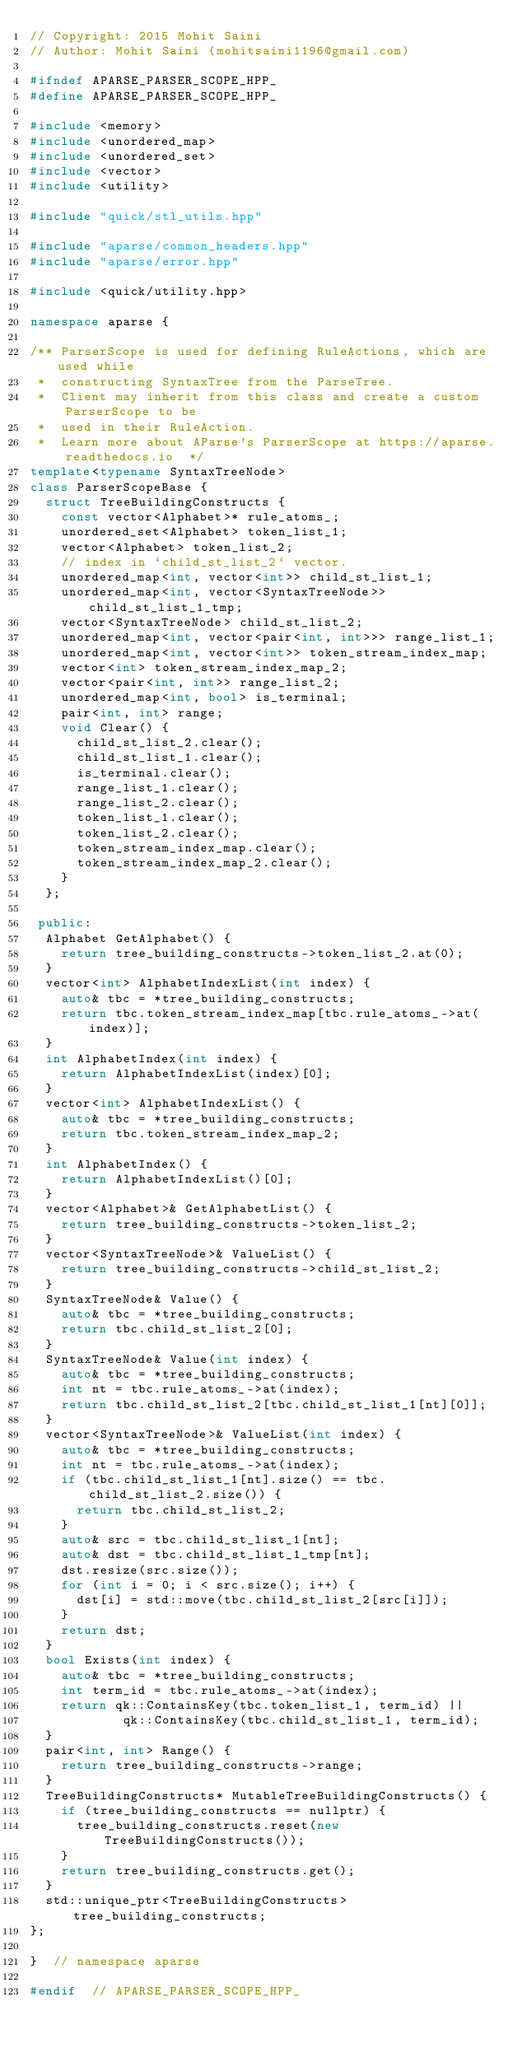<code> <loc_0><loc_0><loc_500><loc_500><_C++_>// Copyright: 2015 Mohit Saini
// Author: Mohit Saini (mohitsaini1196@gmail.com)

#ifndef APARSE_PARSER_SCOPE_HPP_
#define APARSE_PARSER_SCOPE_HPP_

#include <memory>
#include <unordered_map>
#include <unordered_set>
#include <vector>
#include <utility>

#include "quick/stl_utils.hpp"

#include "aparse/common_headers.hpp"
#include "aparse/error.hpp"

#include <quick/utility.hpp>

namespace aparse {

/** ParserScope is used for defining RuleActions, which are used while
 *  constructing SyntaxTree from the ParseTree.
 *  Client may inherit from this class and create a custom ParserScope to be
 *  used in their RuleAction.
 *  Learn more about AParse's ParserScope at https://aparse.readthedocs.io  */
template<typename SyntaxTreeNode>
class ParserScopeBase {
  struct TreeBuildingConstructs {
    const vector<Alphabet>* rule_atoms_;
    unordered_set<Alphabet> token_list_1;
    vector<Alphabet> token_list_2;
    // index in `child_st_list_2` vector.
    unordered_map<int, vector<int>> child_st_list_1;
    unordered_map<int, vector<SyntaxTreeNode>> child_st_list_1_tmp;
    vector<SyntaxTreeNode> child_st_list_2;
    unordered_map<int, vector<pair<int, int>>> range_list_1;
    unordered_map<int, vector<int>> token_stream_index_map;
    vector<int> token_stream_index_map_2;
    vector<pair<int, int>> range_list_2;
    unordered_map<int, bool> is_terminal;
    pair<int, int> range;
    void Clear() {
      child_st_list_2.clear();
      child_st_list_1.clear();
      is_terminal.clear();
      range_list_1.clear();
      range_list_2.clear();
      token_list_1.clear();
      token_list_2.clear();
      token_stream_index_map.clear();
      token_stream_index_map_2.clear();
    }
  };

 public:
  Alphabet GetAlphabet() {
    return tree_building_constructs->token_list_2.at(0);
  }
  vector<int> AlphabetIndexList(int index) {
    auto& tbc = *tree_building_constructs;
    return tbc.token_stream_index_map[tbc.rule_atoms_->at(index)];
  }
  int AlphabetIndex(int index) {
    return AlphabetIndexList(index)[0];
  }
  vector<int> AlphabetIndexList() {
    auto& tbc = *tree_building_constructs;
    return tbc.token_stream_index_map_2;
  }
  int AlphabetIndex() {
    return AlphabetIndexList()[0];
  }
  vector<Alphabet>& GetAlphabetList() {
    return tree_building_constructs->token_list_2;
  }
  vector<SyntaxTreeNode>& ValueList() {
    return tree_building_constructs->child_st_list_2;
  }
  SyntaxTreeNode& Value() {
    auto& tbc = *tree_building_constructs;
    return tbc.child_st_list_2[0];
  }
  SyntaxTreeNode& Value(int index) {
    auto& tbc = *tree_building_constructs;
    int nt = tbc.rule_atoms_->at(index);
    return tbc.child_st_list_2[tbc.child_st_list_1[nt][0]];
  }
  vector<SyntaxTreeNode>& ValueList(int index) {
    auto& tbc = *tree_building_constructs;
    int nt = tbc.rule_atoms_->at(index);
    if (tbc.child_st_list_1[nt].size() == tbc.child_st_list_2.size()) {
      return tbc.child_st_list_2;
    }
    auto& src = tbc.child_st_list_1[nt];
    auto& dst = tbc.child_st_list_1_tmp[nt];
    dst.resize(src.size());
    for (int i = 0; i < src.size(); i++) {
      dst[i] = std::move(tbc.child_st_list_2[src[i]]);
    }
    return dst;
  }
  bool Exists(int index) {
    auto& tbc = *tree_building_constructs;
    int term_id = tbc.rule_atoms_->at(index);
    return qk::ContainsKey(tbc.token_list_1, term_id) ||
            qk::ContainsKey(tbc.child_st_list_1, term_id);
  }
  pair<int, int> Range() {
    return tree_building_constructs->range;
  }
  TreeBuildingConstructs* MutableTreeBuildingConstructs() {
    if (tree_building_constructs == nullptr) {
      tree_building_constructs.reset(new TreeBuildingConstructs());
    }
    return tree_building_constructs.get();
  }
  std::unique_ptr<TreeBuildingConstructs> tree_building_constructs;
};

}  // namespace aparse

#endif  // APARSE_PARSER_SCOPE_HPP_
</code> 